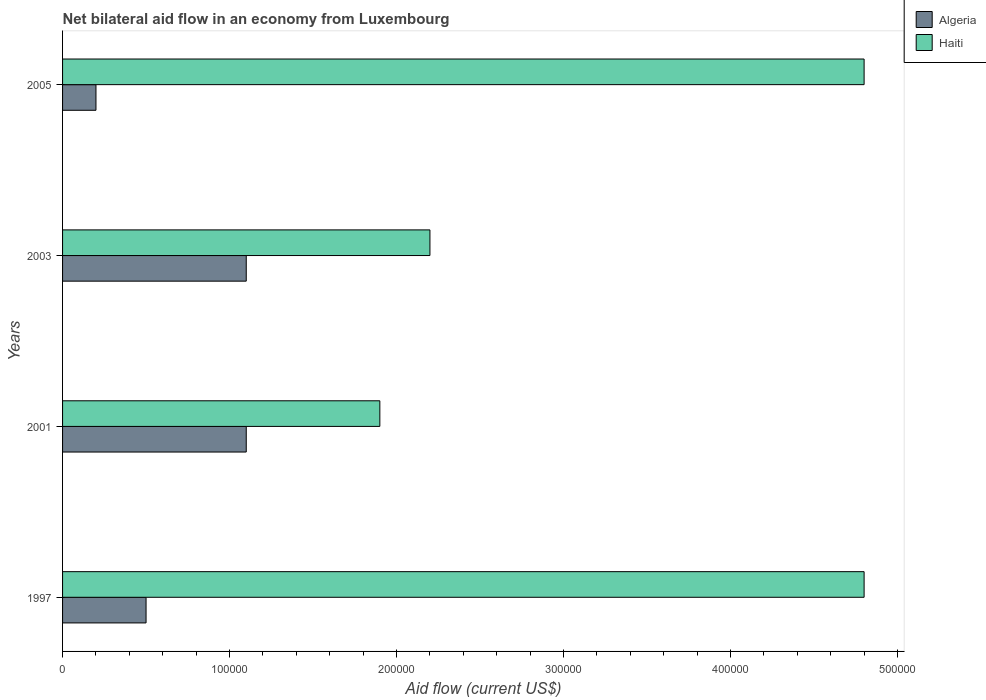What is the label of the 2nd group of bars from the top?
Offer a very short reply. 2003. In how many cases, is the number of bars for a given year not equal to the number of legend labels?
Provide a short and direct response. 0. Across all years, what is the maximum net bilateral aid flow in Haiti?
Provide a succinct answer. 4.80e+05. In which year was the net bilateral aid flow in Algeria minimum?
Your answer should be compact. 2005. What is the difference between the net bilateral aid flow in Algeria in 2001 and that in 2005?
Make the answer very short. 9.00e+04. What is the difference between the net bilateral aid flow in Algeria in 2005 and the net bilateral aid flow in Haiti in 1997?
Give a very brief answer. -4.60e+05. What is the average net bilateral aid flow in Algeria per year?
Make the answer very short. 7.25e+04. In the year 2005, what is the difference between the net bilateral aid flow in Algeria and net bilateral aid flow in Haiti?
Provide a succinct answer. -4.60e+05. In how many years, is the net bilateral aid flow in Algeria greater than 440000 US$?
Your answer should be very brief. 0. Is the net bilateral aid flow in Haiti in 1997 less than that in 2003?
Offer a terse response. No. Is the difference between the net bilateral aid flow in Algeria in 2001 and 2005 greater than the difference between the net bilateral aid flow in Haiti in 2001 and 2005?
Your answer should be very brief. Yes. What is the difference between the highest and the lowest net bilateral aid flow in Haiti?
Make the answer very short. 2.90e+05. In how many years, is the net bilateral aid flow in Haiti greater than the average net bilateral aid flow in Haiti taken over all years?
Offer a very short reply. 2. Is the sum of the net bilateral aid flow in Haiti in 2001 and 2005 greater than the maximum net bilateral aid flow in Algeria across all years?
Offer a terse response. Yes. What does the 2nd bar from the top in 2003 represents?
Your answer should be compact. Algeria. What does the 2nd bar from the bottom in 2005 represents?
Your answer should be compact. Haiti. How many bars are there?
Offer a terse response. 8. Are the values on the major ticks of X-axis written in scientific E-notation?
Your response must be concise. No. How are the legend labels stacked?
Make the answer very short. Vertical. What is the title of the graph?
Ensure brevity in your answer.  Net bilateral aid flow in an economy from Luxembourg. Does "Finland" appear as one of the legend labels in the graph?
Your answer should be compact. No. What is the label or title of the Y-axis?
Your response must be concise. Years. What is the Aid flow (current US$) of Algeria in 1997?
Your response must be concise. 5.00e+04. What is the Aid flow (current US$) in Algeria in 2003?
Your response must be concise. 1.10e+05. Across all years, what is the maximum Aid flow (current US$) of Algeria?
Give a very brief answer. 1.10e+05. What is the total Aid flow (current US$) in Haiti in the graph?
Your response must be concise. 1.37e+06. What is the difference between the Aid flow (current US$) in Algeria in 1997 and that in 2003?
Make the answer very short. -6.00e+04. What is the difference between the Aid flow (current US$) in Algeria in 1997 and that in 2005?
Your answer should be compact. 3.00e+04. What is the difference between the Aid flow (current US$) of Algeria in 2001 and that in 2003?
Make the answer very short. 0. What is the difference between the Aid flow (current US$) in Haiti in 2001 and that in 2005?
Give a very brief answer. -2.90e+05. What is the difference between the Aid flow (current US$) of Algeria in 2003 and that in 2005?
Provide a succinct answer. 9.00e+04. What is the difference between the Aid flow (current US$) of Algeria in 1997 and the Aid flow (current US$) of Haiti in 2001?
Make the answer very short. -1.40e+05. What is the difference between the Aid flow (current US$) in Algeria in 1997 and the Aid flow (current US$) in Haiti in 2005?
Keep it short and to the point. -4.30e+05. What is the difference between the Aid flow (current US$) in Algeria in 2001 and the Aid flow (current US$) in Haiti in 2003?
Give a very brief answer. -1.10e+05. What is the difference between the Aid flow (current US$) of Algeria in 2001 and the Aid flow (current US$) of Haiti in 2005?
Your answer should be very brief. -3.70e+05. What is the difference between the Aid flow (current US$) of Algeria in 2003 and the Aid flow (current US$) of Haiti in 2005?
Ensure brevity in your answer.  -3.70e+05. What is the average Aid flow (current US$) of Algeria per year?
Provide a succinct answer. 7.25e+04. What is the average Aid flow (current US$) in Haiti per year?
Offer a terse response. 3.42e+05. In the year 1997, what is the difference between the Aid flow (current US$) of Algeria and Aid flow (current US$) of Haiti?
Provide a succinct answer. -4.30e+05. In the year 2001, what is the difference between the Aid flow (current US$) in Algeria and Aid flow (current US$) in Haiti?
Your answer should be very brief. -8.00e+04. In the year 2003, what is the difference between the Aid flow (current US$) in Algeria and Aid flow (current US$) in Haiti?
Provide a short and direct response. -1.10e+05. In the year 2005, what is the difference between the Aid flow (current US$) in Algeria and Aid flow (current US$) in Haiti?
Give a very brief answer. -4.60e+05. What is the ratio of the Aid flow (current US$) of Algeria in 1997 to that in 2001?
Make the answer very short. 0.45. What is the ratio of the Aid flow (current US$) of Haiti in 1997 to that in 2001?
Give a very brief answer. 2.53. What is the ratio of the Aid flow (current US$) in Algeria in 1997 to that in 2003?
Your response must be concise. 0.45. What is the ratio of the Aid flow (current US$) of Haiti in 1997 to that in 2003?
Provide a short and direct response. 2.18. What is the ratio of the Aid flow (current US$) in Algeria in 1997 to that in 2005?
Your answer should be very brief. 2.5. What is the ratio of the Aid flow (current US$) of Haiti in 1997 to that in 2005?
Keep it short and to the point. 1. What is the ratio of the Aid flow (current US$) of Haiti in 2001 to that in 2003?
Keep it short and to the point. 0.86. What is the ratio of the Aid flow (current US$) of Algeria in 2001 to that in 2005?
Give a very brief answer. 5.5. What is the ratio of the Aid flow (current US$) of Haiti in 2001 to that in 2005?
Your answer should be very brief. 0.4. What is the ratio of the Aid flow (current US$) in Algeria in 2003 to that in 2005?
Your answer should be compact. 5.5. What is the ratio of the Aid flow (current US$) in Haiti in 2003 to that in 2005?
Your response must be concise. 0.46. What is the difference between the highest and the second highest Aid flow (current US$) of Algeria?
Provide a short and direct response. 0. 